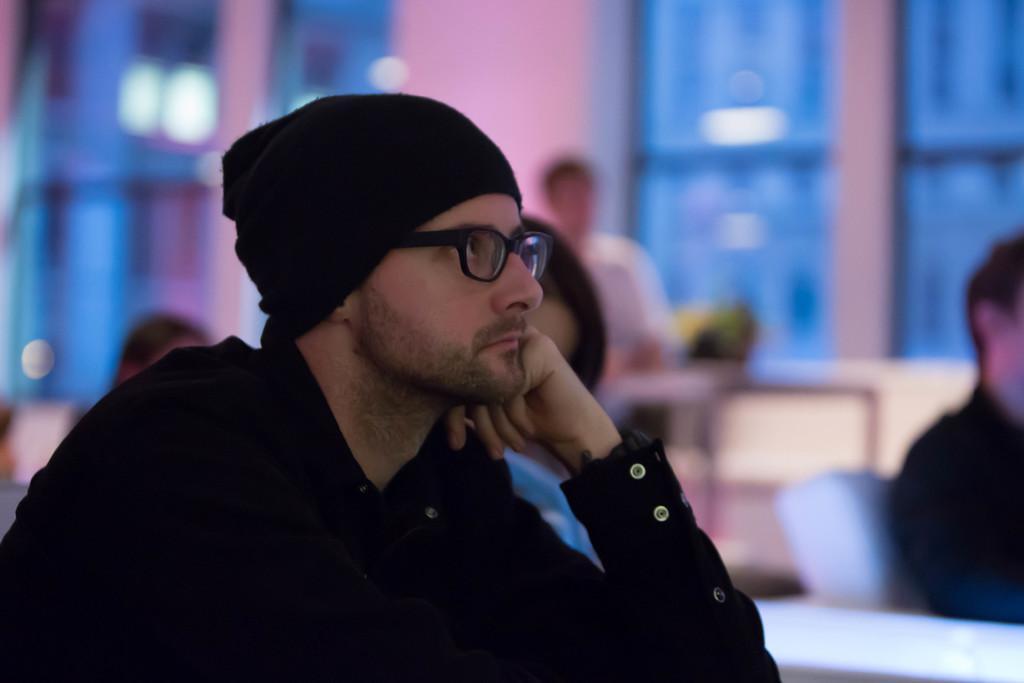Describe this image in one or two sentences. This picture is of inside. On the left there is a man wearing black color shirt and seems to be sitting. On the right there is a man sitting on the chair. In the background there is a person sitting on the chair and there is a table on the top of which some item is placed and there are two windows and through the window we can see the buildings. 